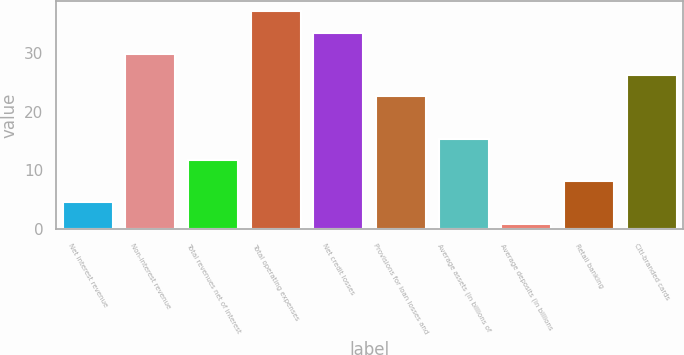Convert chart. <chart><loc_0><loc_0><loc_500><loc_500><bar_chart><fcel>Net interest revenue<fcel>Non-interest revenue<fcel>Total revenues net of interest<fcel>Total operating expenses<fcel>Net credit losses<fcel>Provisions for loan losses and<fcel>Average assets (in billions of<fcel>Average deposits (in billions<fcel>Retail banking<fcel>Citi-branded cards<nl><fcel>4.6<fcel>29.8<fcel>11.8<fcel>37<fcel>33.4<fcel>22.6<fcel>15.4<fcel>1<fcel>8.2<fcel>26.2<nl></chart> 